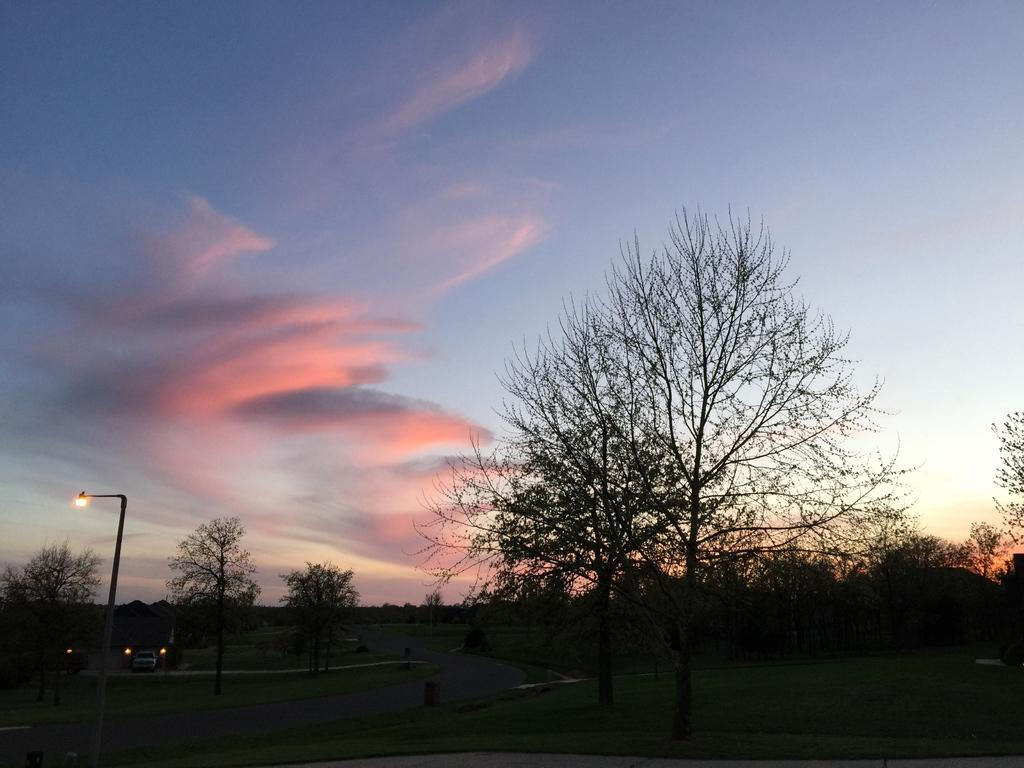What type of vegetation can be seen in the image? There are trees in the image. What is visible at the top of the image? The sky is visible at the top of the image. How many babies are sitting on the branches of the trees in the image? There are no babies present in the image; it only features trees and the sky. What type of soda is being poured into the trees in the image? There is no soda present in the image; it only features trees and the sky. 